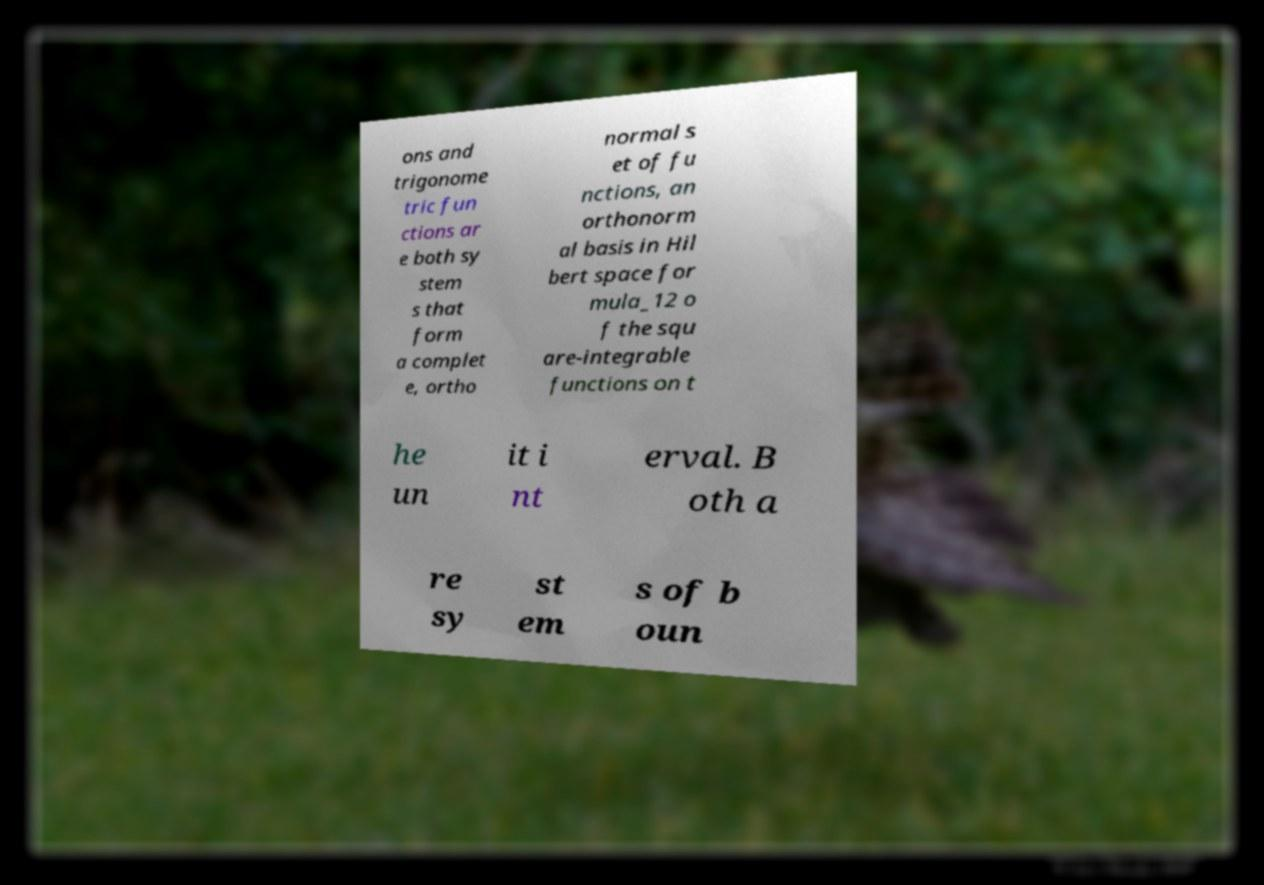For documentation purposes, I need the text within this image transcribed. Could you provide that? ons and trigonome tric fun ctions ar e both sy stem s that form a complet e, ortho normal s et of fu nctions, an orthonorm al basis in Hil bert space for mula_12 o f the squ are-integrable functions on t he un it i nt erval. B oth a re sy st em s of b oun 